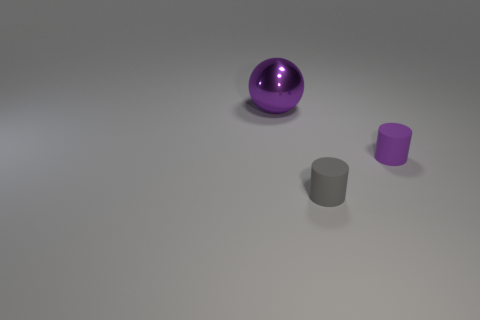Add 3 small brown metal objects. How many objects exist? 6 Subtract 1 spheres. How many spheres are left? 0 Subtract all balls. How many objects are left? 2 Subtract all red cubes. How many blue balls are left? 0 Subtract all gray cylinders. How many cylinders are left? 1 Subtract all blue cylinders. Subtract all purple blocks. How many cylinders are left? 2 Add 1 tiny cylinders. How many tiny cylinders are left? 3 Add 2 yellow matte objects. How many yellow matte objects exist? 2 Subtract 0 green balls. How many objects are left? 3 Subtract all big purple spheres. Subtract all tiny purple rubber things. How many objects are left? 1 